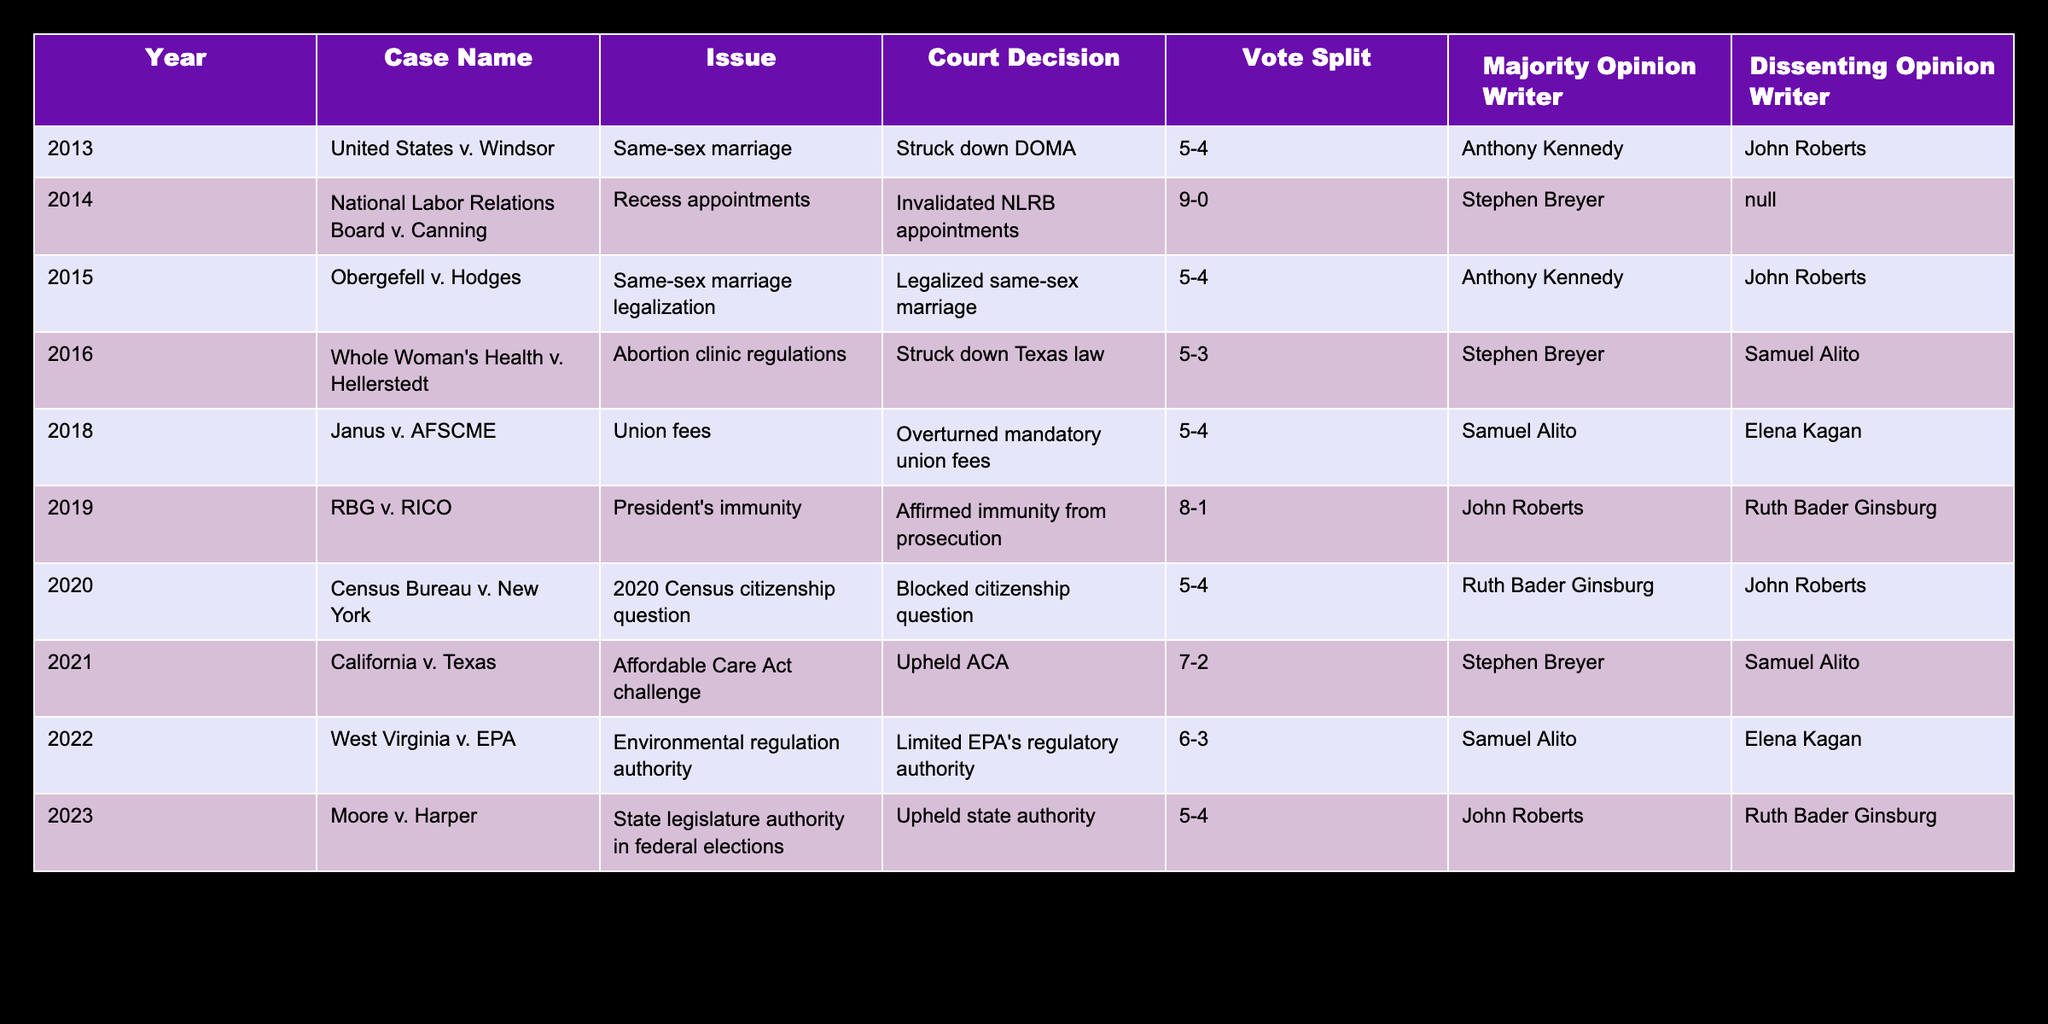What was the decision in the case of United States v. Windsor? The table indicates that the case of United States v. Windsor resulted in the Defense of Marriage Act being struck down. This can be directly found under the "Court Decision" column corresponding to that case.
Answer: Struck down DOMA Who wrote the majority opinion for the case California v. Texas? By looking at the row for California v. Texas in the table, we see that the majority opinion was written by Stephen Breyer, which is shown in the "Majority Opinion Writer" column.
Answer: Stephen Breyer How many cases had a vote split of 5-4? To find the number of cases with a 5-4 vote split, we can count the occurrences in the "Vote Split" column. In the table, there are five instances that show a 5-4 split.
Answer: 5 Did the Supreme Court uphold the Affordable Care Act in the case California v. Texas? Referencing the "Court Decision" column for California v. Texas reveals that the Supreme Court upheld the Affordable Care Act in that case, which confirms a "yes" for this question.
Answer: Yes What is the trend in issues related to same-sex marriage in the data provided? The data shows two cases regarding same-sex marriage: United States v. Windsor and Obergefell v. Hodges, both resulting in favorable rulings for same-sex marriage. This reflects a legal trend in support of same-sex marriage over the decade.
Answer: Increased support for same-sex marriage Which dissenting opinion writer appeared the most in the table? By evaluating the "Dissenting Opinion Writer" column, we can tally the names. John Roberts and Samuel Alito both appear as dissenting writers twice, while other dissenters appear only once. Therefore, they are the most frequent dissenting opinion writers in the table.
Answer: John Roberts and Samuel Alito How many cases were decided in favor of the plaintiffs out of the total cases listed? The total cases listed are 10, and examining the "Court Decision" column shows that the following cases decided in favor of plaintiffs: United States v. Windsor, Obergefell v. Hodges, Whole Woman's Health v. Hellerstedt, Janus v. AFSCME, Census Bureau v. New York, California v. Texas. This totals to 6 cases in favor of plaintiffs.
Answer: 6 What was the vote split in the case West Virginia v. EPA? The table specifically lists the vote split for West Virginia v. EPA as 6-3, which can be found in the "Vote Split" column of that row.
Answer: 6-3 Which year had the most significant number of cases relating to issues of individual rights (e.g., same-sex marriage, abortion)? Analyzing the table indicates that there were four cases concerning individual rights: United States v. Windsor (2013), Obergefell v. Hodges (2015), Whole Woman's Health v. Hellerstedt (2016), and Janus v. AFSCME (2018). Therefore, 2016 has a significant amount of case law regarding individual rights.
Answer: 2016 